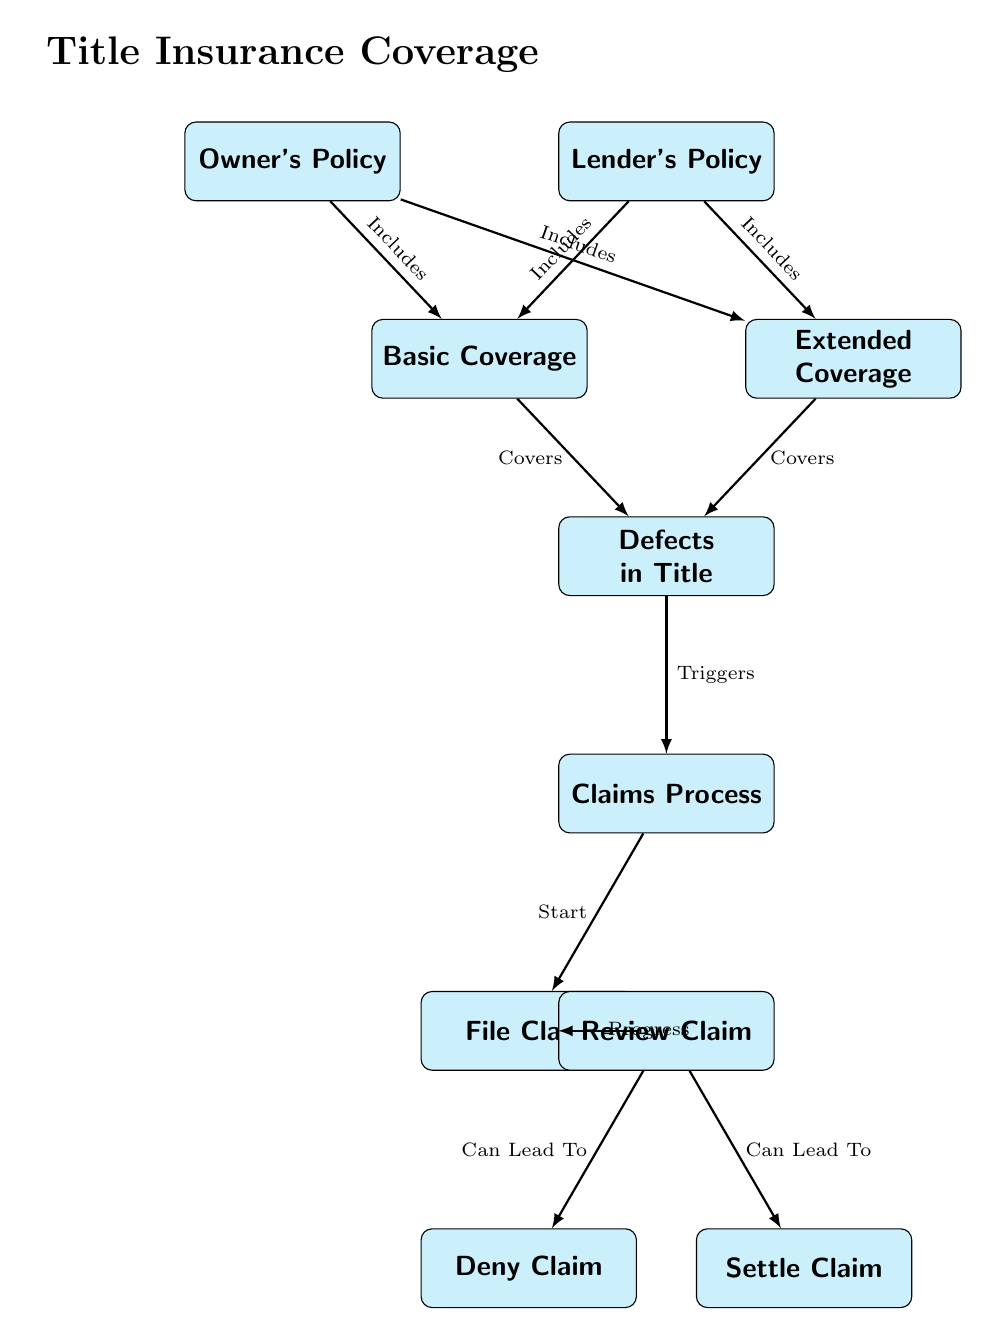What are the two types of title insurance policies shown? The diagram specifies two types of title insurance policies: Owner's Policy and Lender's Policy. These policies are represented as distinct nodes in the diagram.
Answer: Owner's Policy, Lender's Policy How many types of coverage are detailed in the diagram? The diagram outlines two types of coverage: Basic Coverage and Extended Coverage, which are linked to both the Owner's Policy and the Lender's Policy.
Answer: 2 What triggers the claims process according to the diagram? The diagram indicates that defects in title trigger the claims process. This relationship can be traced directly from the "Defects in Title" node to the "Claims Process" node.
Answer: Defects in Title What can happen after a claim is reviewed? The diagram shows that after a claim is reviewed, it can either lead to a denial or a settlement of the claim. This is illustrated by the outgoing edges from the "Review Claim" node.
Answer: Deny Claim, Settle Claim Which types of title insurance include basic coverage? The diagram explicitly states that both the Owner's Policy and the Lender's Policy include basic coverage, as indicated by the connecting edges from both policy nodes to the Basic Coverage node.
Answer: Owner's Policy, Lender's Policy What is the first step in the claims process? According to the diagram, the first step in the claims process is to file a claim, which is represented as the starting node connected to the "Claims Process" node.
Answer: File Claim How do extended coverage and basic coverage relate to defects in title? Both extended coverage and basic coverage cover defects in title, as illustrated by the connections from the "Basic Coverage" node and the "Extended Coverage" node to the "Defects in Title" node.
Answer: Covers What visual element indicates the title of the diagram? The diagram features a title at the top, set in larger font size, stating "Title Insurance Coverage," which is a visual distinction that clearly indicates what the diagram is about.
Answer: Title Insurance Coverage How are the nodes visually characterized in the diagram? The nodes are characterized by a specific style that includes rounded corners, a cyan fill, bold text, and a designated minimum height, creating a visually distinct layout for each policy and process.
Answer: Rounded corners, cyan fill, bold text 